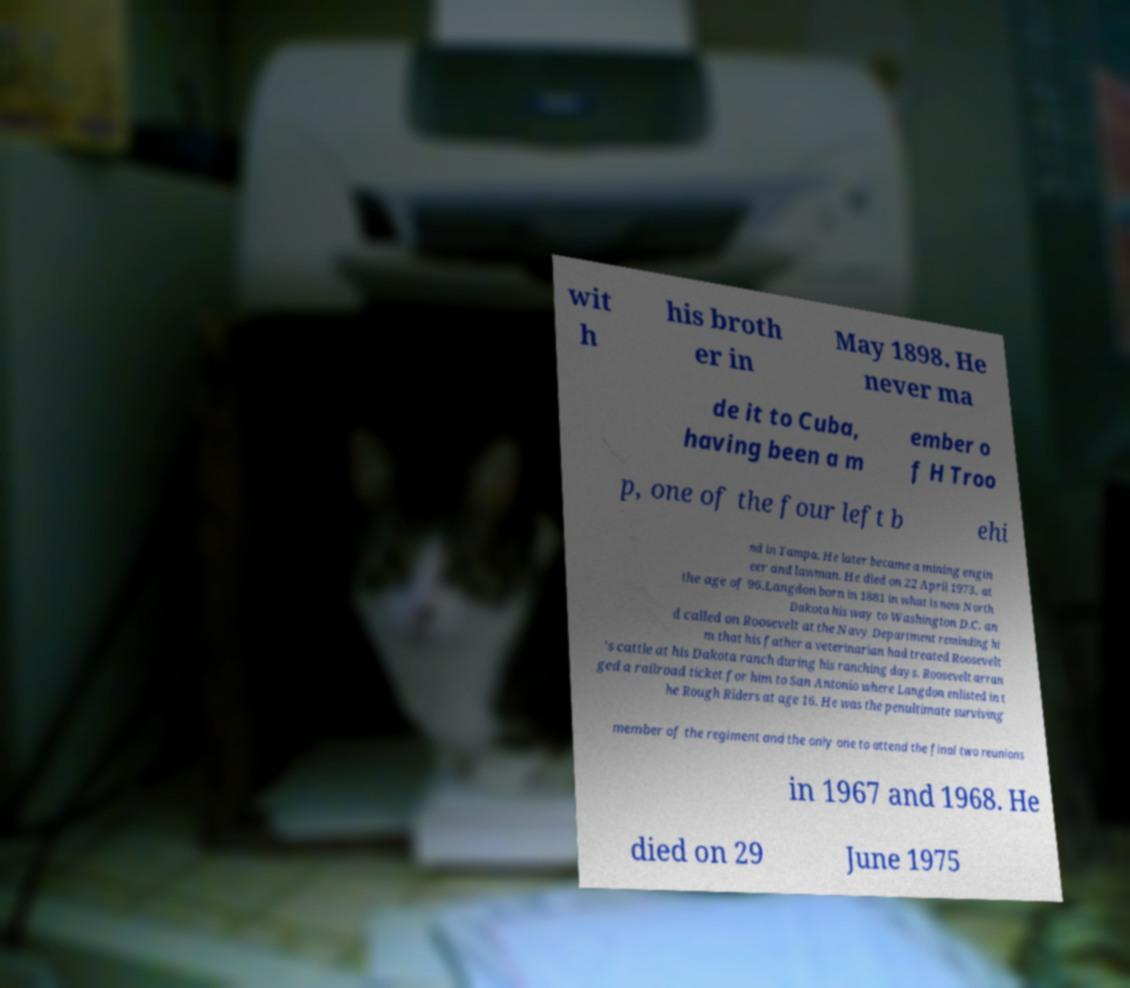Please read and relay the text visible in this image. What does it say? wit h his broth er in May 1898. He never ma de it to Cuba, having been a m ember o f H Troo p, one of the four left b ehi nd in Tampa. He later became a mining engin eer and lawman. He died on 22 April 1973, at the age of 96.Langdon born in 1881 in what is now North Dakota his way to Washington D.C. an d called on Roosevelt at the Navy Department reminding hi m that his father a veterinarian had treated Roosevelt 's cattle at his Dakota ranch during his ranching days. Roosevelt arran ged a railroad ticket for him to San Antonio where Langdon enlisted in t he Rough Riders at age 16. He was the penultimate surviving member of the regiment and the only one to attend the final two reunions in 1967 and 1968. He died on 29 June 1975 